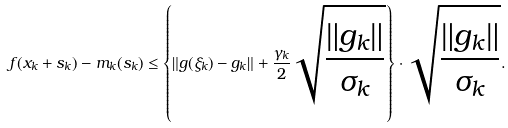Convert formula to latex. <formula><loc_0><loc_0><loc_500><loc_500>f ( x _ { k } + s _ { k } ) - m _ { k } ( s _ { k } ) \leq \left \{ \| g ( \xi _ { k } ) - g _ { k } \| + \frac { \gamma _ { k } } 2 \sqrt { \frac { \| g _ { k } \| } { \sigma _ { k } } } \right \} \cdot \sqrt { \frac { \| g _ { k } \| } { \sigma _ { k } } } .</formula> 